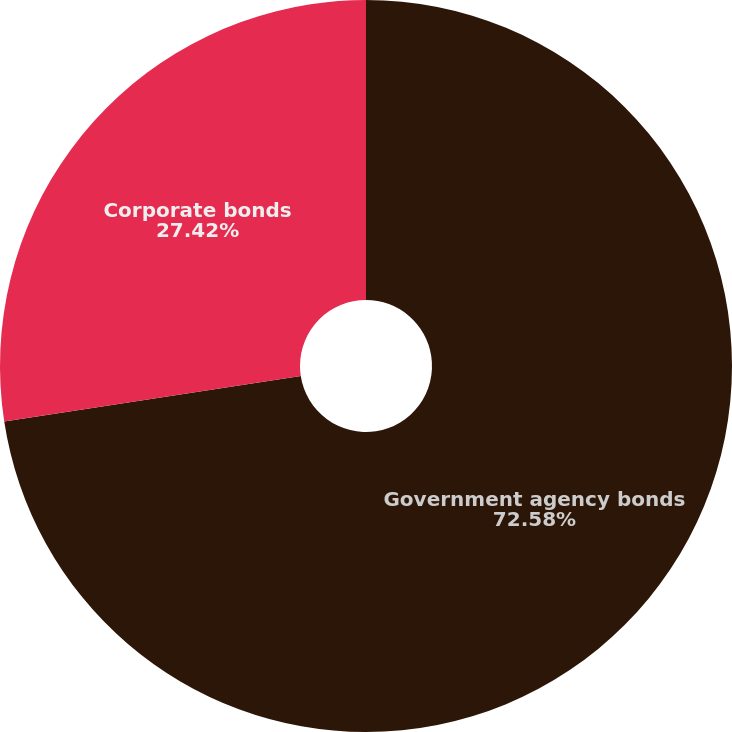<chart> <loc_0><loc_0><loc_500><loc_500><pie_chart><fcel>Government agency bonds<fcel>Corporate bonds<nl><fcel>72.58%<fcel>27.42%<nl></chart> 